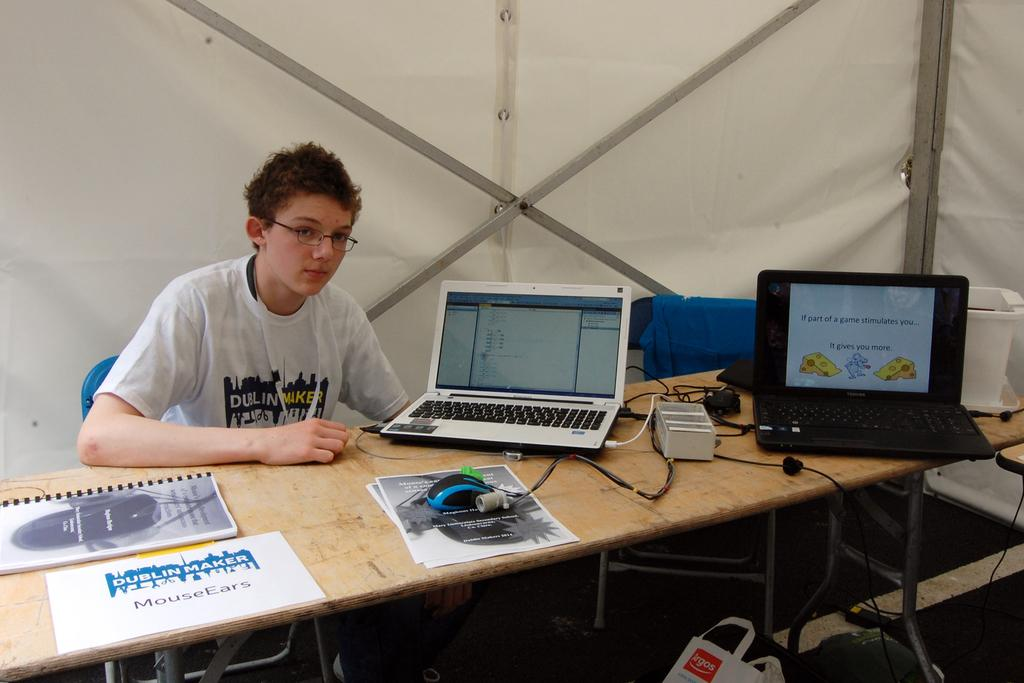<image>
Share a concise interpretation of the image provided. A young man sitting at a desk advertising something called Mouse Ears. 